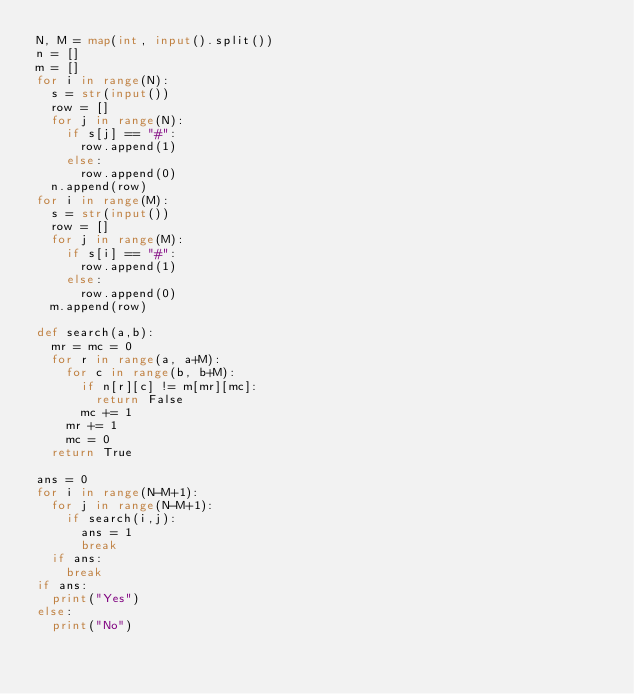Convert code to text. <code><loc_0><loc_0><loc_500><loc_500><_Python_>N, M = map(int, input().split())
n = []
m = []
for i in range(N):
  s = str(input())
  row = []
  for j in range(N):
    if s[j] == "#":
      row.append(1)
    else:
      row.append(0)
  n.append(row)
for i in range(M):
  s = str(input())
  row = []
  for j in range(M):
    if s[i] == "#":
      row.append(1)
    else:
      row.append(0)
  m.append(row)
 
def search(a,b):
  mr = mc = 0
  for r in range(a, a+M):
    for c in range(b, b+M):
      if n[r][c] != m[mr][mc]:
        return False
      mc += 1
    mr += 1
    mc = 0
  return True

ans = 0
for i in range(N-M+1):
  for j in range(N-M+1):
    if search(i,j):
      ans = 1
      break
  if ans:
    break
if ans:
  print("Yes")
else:
  print("No")</code> 